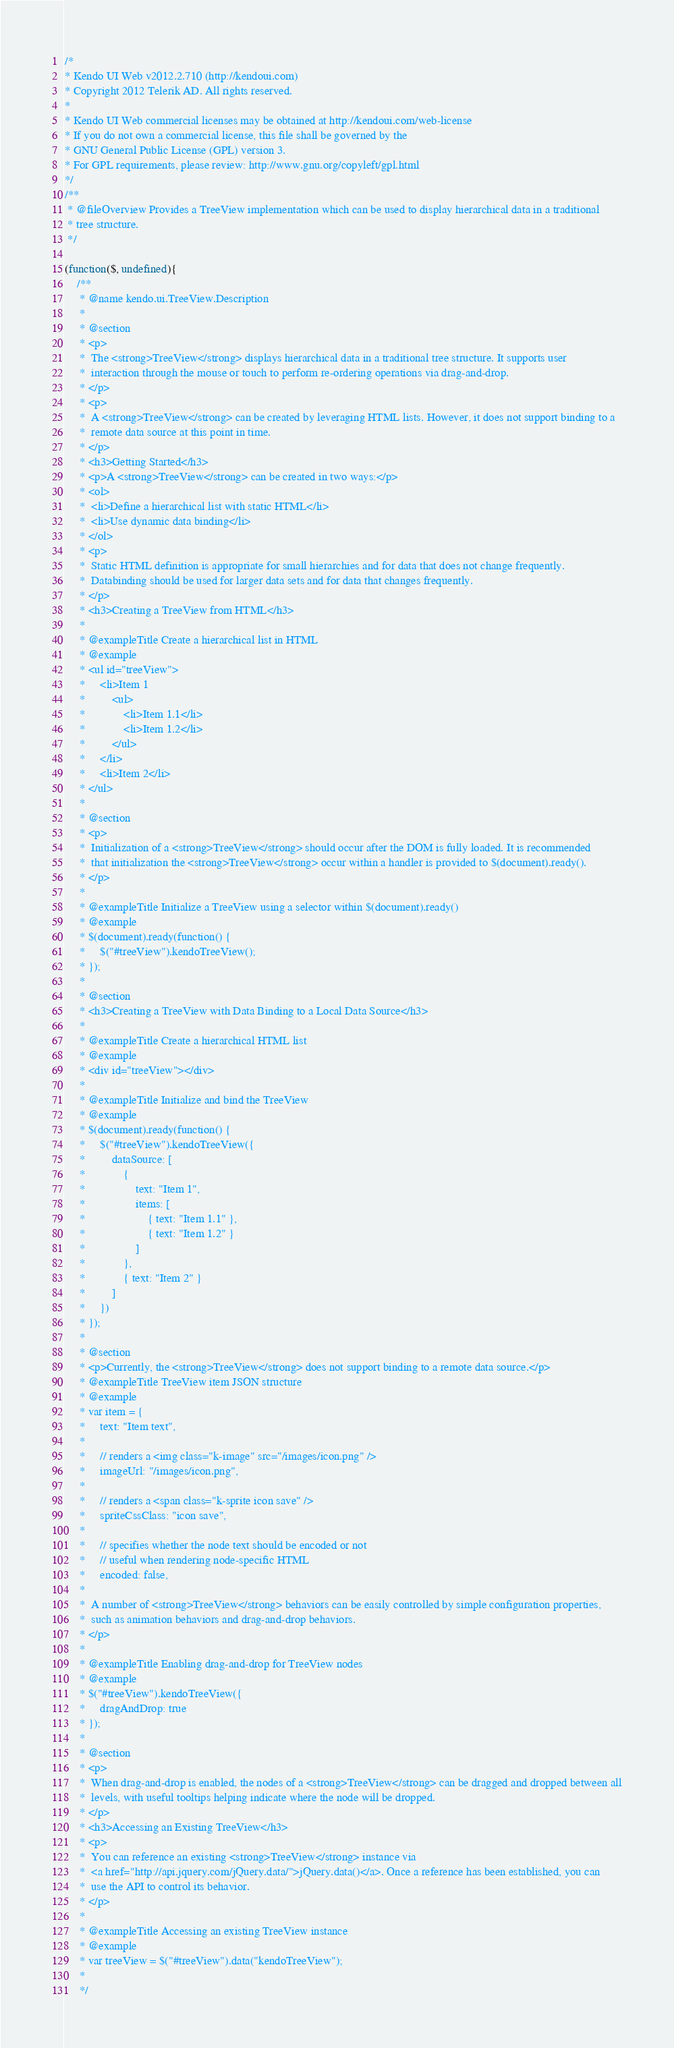Convert code to text. <code><loc_0><loc_0><loc_500><loc_500><_JavaScript_>/*
* Kendo UI Web v2012.2.710 (http://kendoui.com)
* Copyright 2012 Telerik AD. All rights reserved.
*
* Kendo UI Web commercial licenses may be obtained at http://kendoui.com/web-license
* If you do not own a commercial license, this file shall be governed by the
* GNU General Public License (GPL) version 3.
* For GPL requirements, please review: http://www.gnu.org/copyleft/gpl.html
*/
/**
 * @fileOverview Provides a TreeView implementation which can be used to display hierarchical data in a traditional
 * tree structure.
 */

(function($, undefined){
    /**
     * @name kendo.ui.TreeView.Description
     *
     * @section
     * <p>
     *  The <strong>TreeView</strong> displays hierarchical data in a traditional tree structure. It supports user
     *  interaction through the mouse or touch to perform re-ordering operations via drag-and-drop.
     * </p>
     * <p>
     *  A <strong>TreeView</strong> can be created by leveraging HTML lists. However, it does not support binding to a
     *  remote data source at this point in time.
     * </p>
     * <h3>Getting Started</h3>
     * <p>A <strong>TreeView</strong> can be created in two ways:</p>
     * <ol>
     *  <li>Define a hierarchical list with static HTML</li>
     *  <li>Use dynamic data binding</li>
     * </ol>
     * <p>
     *  Static HTML definition is appropriate for small hierarchies and for data that does not change frequently.
     *  Databinding should be used for larger data sets and for data that changes frequently.
     * </p>
     * <h3>Creating a TreeView from HTML</h3>
     *
     * @exampleTitle Create a hierarchical list in HTML
     * @example
     * <ul id="treeView">
     *     <li>Item 1
     *         <ul>
     *             <li>Item 1.1</li>
     *             <li>Item 1.2</li>
     *         </ul>
     *     </li>
     *     <li>Item 2</li>
     * </ul>
     *
     * @section
     * <p>
     *  Initialization of a <strong>TreeView</strong> should occur after the DOM is fully loaded. It is recommended
     *  that initialization the <strong>TreeView</strong> occur within a handler is provided to $(document).ready().
     * </p>
     *
     * @exampleTitle Initialize a TreeView using a selector within $(document).ready()
     * @example
     * $(document).ready(function() {
     *     $("#treeView").kendoTreeView();
     * });
     *
     * @section
     * <h3>Creating a TreeView with Data Binding to a Local Data Source</h3>
     *
     * @exampleTitle Create a hierarchical HTML list
     * @example
     * <div id="treeView"></div>
     *
     * @exampleTitle Initialize and bind the TreeView
     * @example
     * $(document).ready(function() {
     *     $("#treeView").kendoTreeView({
     *         dataSource: [
     *             {
     *                 text: "Item 1",
     *                 items: [
     *                     { text: "Item 1.1" },
     *                     { text: "Item 1.2" }
     *                 ]
     *             },
     *             { text: "Item 2" }
     *         ]
     *     })
     * });
     *
     * @section
     * <p>Currently, the <strong>TreeView</strong> does not support binding to a remote data source.</p>
     * @exampleTitle TreeView item JSON structure
     * @example
     * var item = {
     *     text: "Item text",
     *
     *     // renders a <img class="k-image" src="/images/icon.png" />
     *     imageUrl: "/images/icon.png",
     *
     *     // renders a <span class="k-sprite icon save" />
     *     spriteCssClass: "icon save",
     *
     *     // specifies whether the node text should be encoded or not
     *     // useful when rendering node-specific HTML
     *     encoded: false,
     *
     *  A number of <strong>TreeView</strong> behaviors can be easily controlled by simple configuration properties,
     *  such as animation behaviors and drag-and-drop behaviors.
     * </p>
     *
     * @exampleTitle Enabling drag-and-drop for TreeView nodes
     * @example
     * $("#treeView").kendoTreeView({
     *     dragAndDrop: true
     * });
     *
     * @section
     * <p>
     *  When drag-and-drop is enabled, the nodes of a <strong>TreeView</strong> can be dragged and dropped between all
     *  levels, with useful tooltips helping indicate where the node will be dropped.
     * </p>
     * <h3>Accessing an Existing TreeView</h3>
     * <p>
     *  You can reference an existing <strong>TreeView</strong> instance via
     *  <a href="http://api.jquery.com/jQuery.data/">jQuery.data()</a>. Once a reference has been established, you can
     *  use the API to control its behavior.
     * </p>
     *
     * @exampleTitle Accessing an existing TreeView instance
     * @example
     * var treeView = $("#treeView").data("kendoTreeView");
     *
     */</code> 